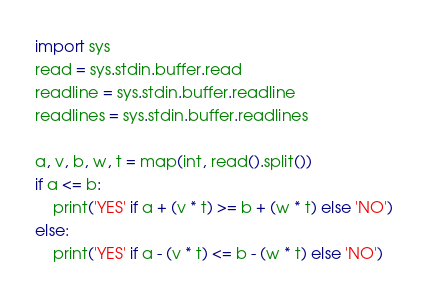Convert code to text. <code><loc_0><loc_0><loc_500><loc_500><_Python_>import sys
read = sys.stdin.buffer.read
readline = sys.stdin.buffer.readline
readlines = sys.stdin.buffer.readlines

a, v, b, w, t = map(int, read().split())
if a <= b:
    print('YES' if a + (v * t) >= b + (w * t) else 'NO')
else:
    print('YES' if a - (v * t) <= b - (w * t) else 'NO')</code> 